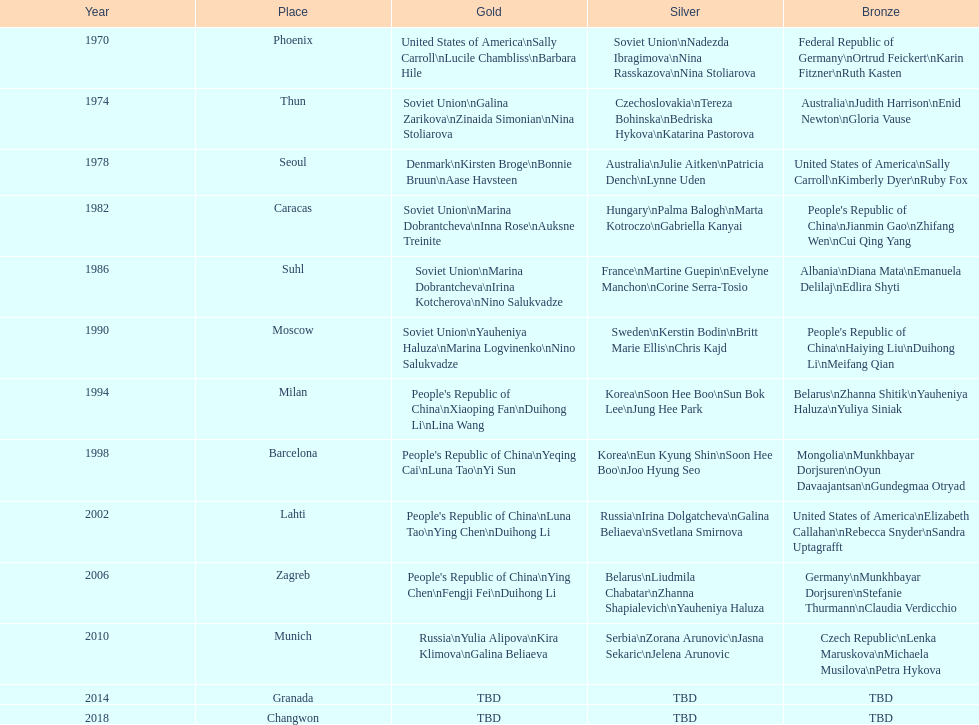Which country is most often mentioned in the silver column? Korea. 